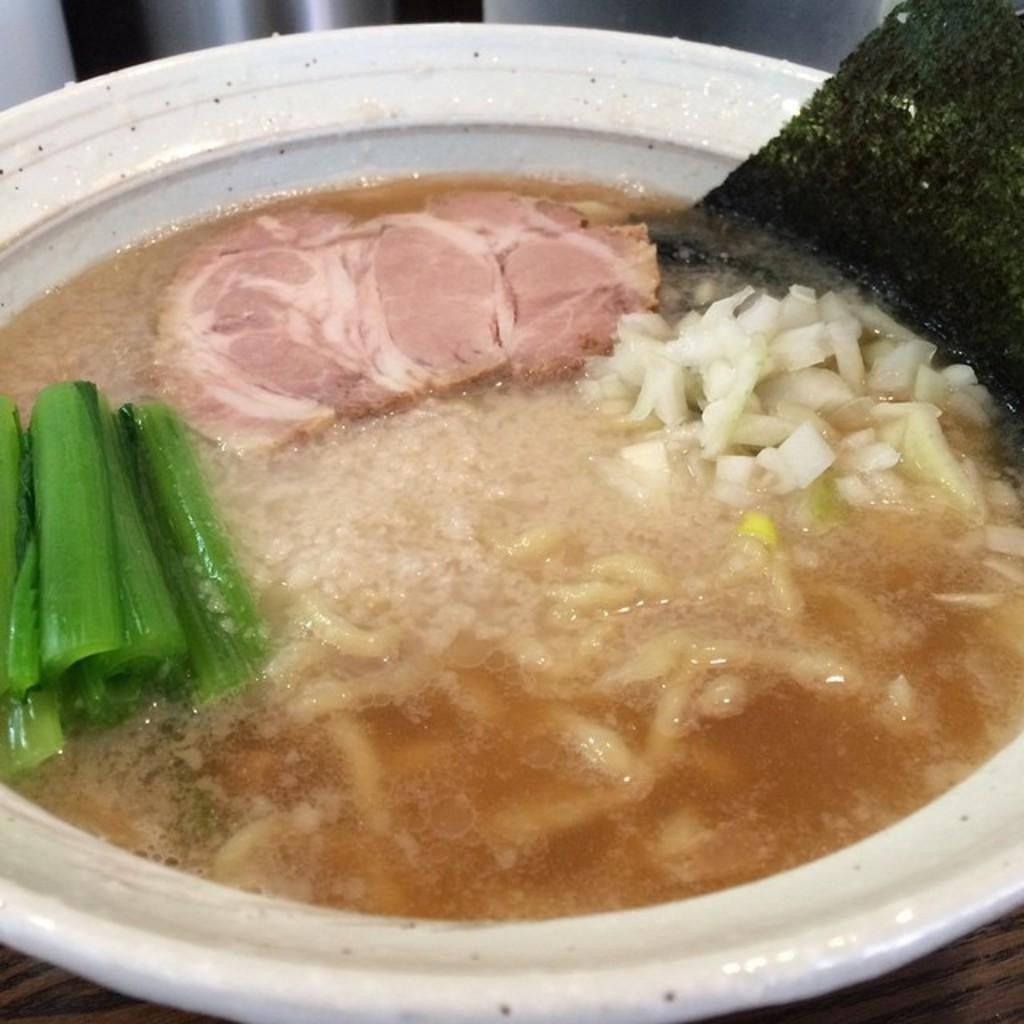What is in the bowl that is visible in the image? There is food in a bowl in the image. What type of furniture is present in the image? There is a table in the image. What type of pail is used to serve the food in the image? There is no pail present in the image; the food is served in a bowl. Can you see any dinosaurs in the image? No, there are no dinosaurs present in the image. 